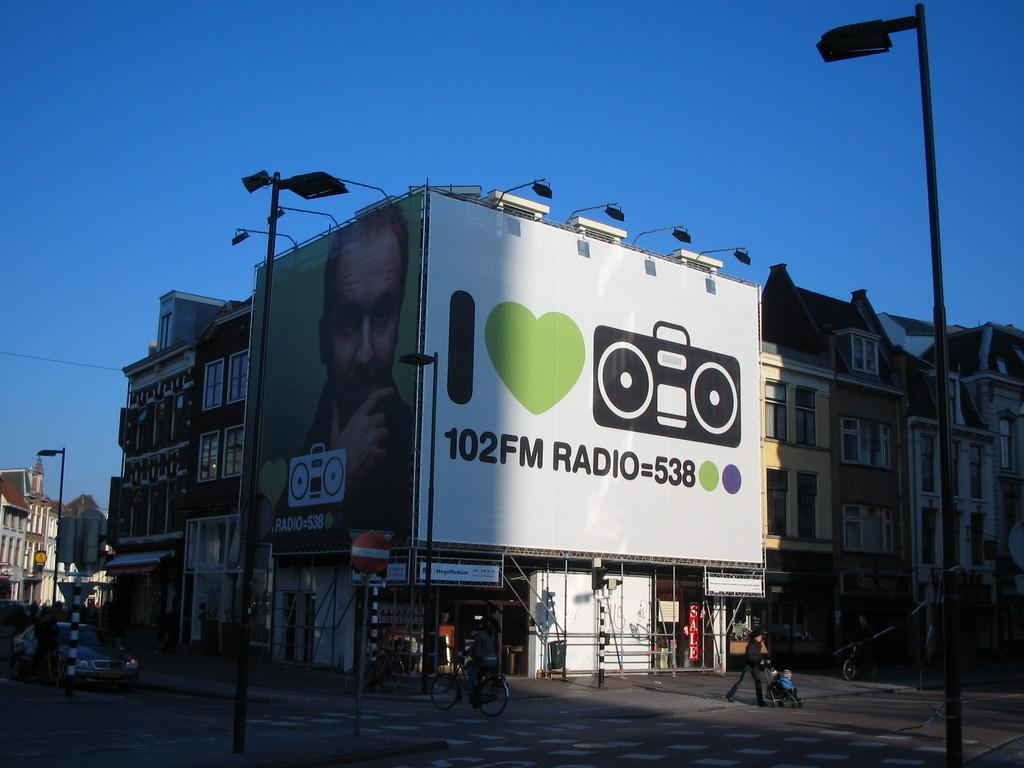<image>
Create a compact narrative representing the image presented. A huge billboard for 102 FM Radio is hanging from a building. 